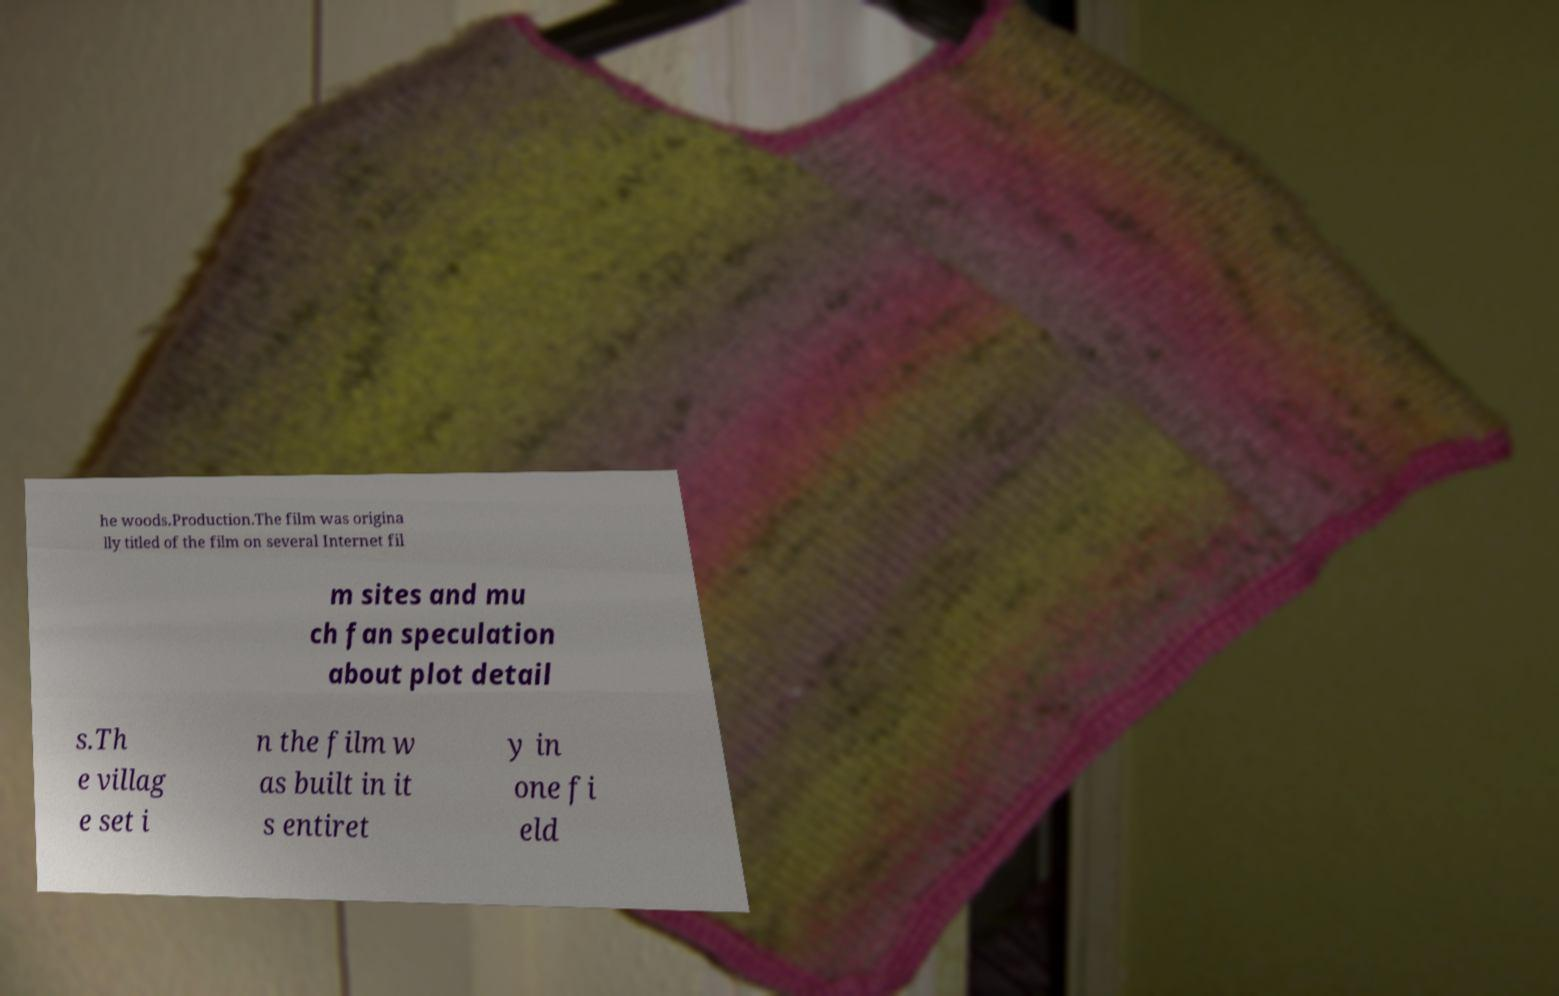I need the written content from this picture converted into text. Can you do that? he woods.Production.The film was origina lly titled of the film on several Internet fil m sites and mu ch fan speculation about plot detail s.Th e villag e set i n the film w as built in it s entiret y in one fi eld 